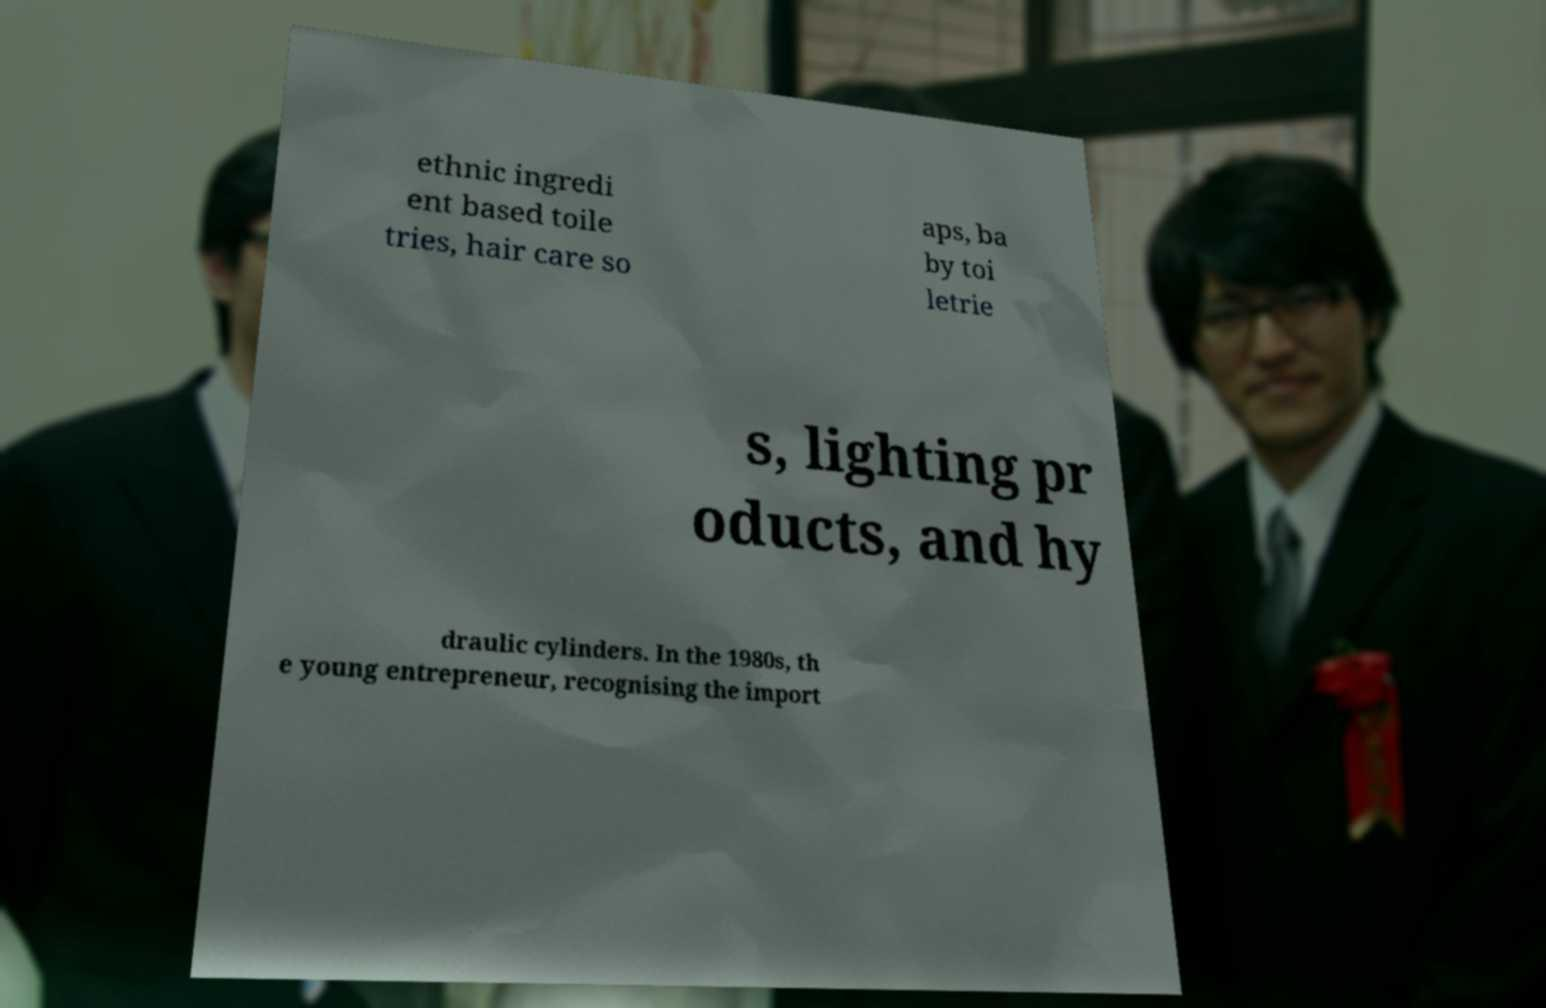What messages or text are displayed in this image? I need them in a readable, typed format. ethnic ingredi ent based toile tries, hair care so aps, ba by toi letrie s, lighting pr oducts, and hy draulic cylinders. In the 1980s, th e young entrepreneur, recognising the import 